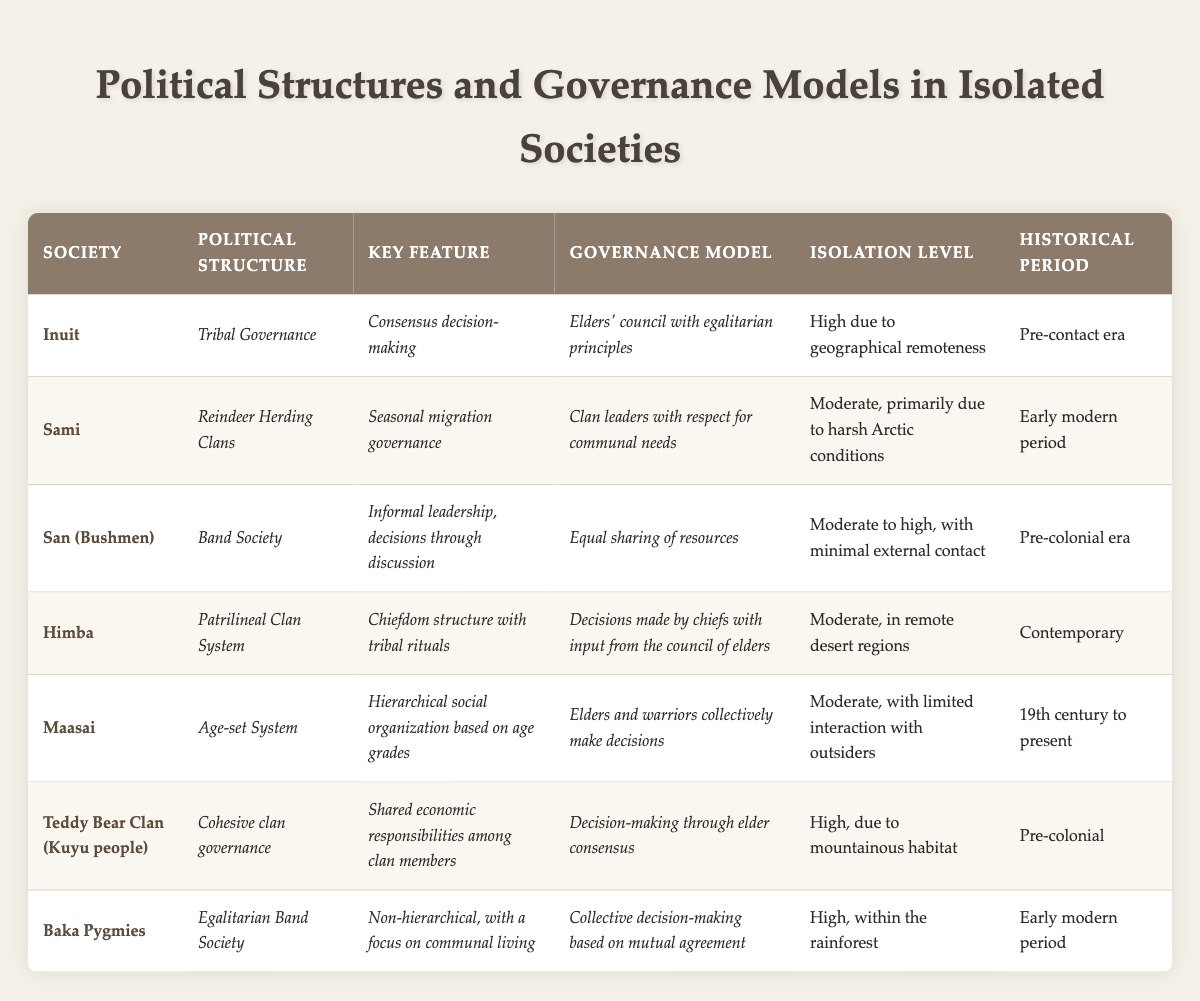What is the political structure of the Inuit society? The Inuit society's political structure is explicitly listed in the table as "Tribal Governance."
Answer: Tribal Governance Which society has a governance model based on communal needs? The governance model of the Sami society prioritizes communal needs, as stated in the table.
Answer: Sami Is the isolation level of the Baka Pygmies high? The table states that the isolation level for the Baka Pygmies is "High," confirming the statement is true.
Answer: Yes What historical period is associated with the Teddy Bear Clan? According to the table, the historical period associated with the Teddy Bear Clan is "Pre-colonial."
Answer: Pre-colonial How many societies listed have a high isolation level? There are four societies with a high isolation level: Inuit, Teddy Bear Clan, Baka Pygmies, and one more. Counting these gives a total of four.
Answer: 4 Which political structure is common among the societies with moderate isolation levels? The political structures of the Sami, Himba, and Maasai societies are all classified under "moderate" isolation levels, with the notable structure being clan or age-based governance.
Answer: Clan or Age-based Governance What key feature is unique to the Himba political structure? The key feature of the Himba’s political structure is "Chiefdom structure with tribal rituals," as noted in the table.
Answer: Chiefdom structure with tribal rituals Which society relies on seasonal migration governance? The Sami society's governance is explicitly described as relying on seasonal migration.
Answer: Sami How does the governance model of the San (Bushmen) society promote equality? The San society promotes equality through an "Equal sharing of resources" governance model, which emphasizes communal decision-making as indicated in the table.
Answer: Equal sharing of resources Are all societies listed in the table egalitarian in their governance models? The table shows that while some societies like the Baka Pygmies and San exhibit egalitarian traits, others such as the Himba and Maasai do have hierarchical elements, indicating that not all are purely egalitarian.
Answer: No What governance model is used by the Maasai? The governance model for the Maasai society is described as "Elders and warriors collectively make decisions," highlighting their decision-making process.
Answer: Elders and warriors collectively make decisions 